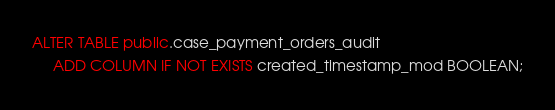Convert code to text. <code><loc_0><loc_0><loc_500><loc_500><_SQL_>ALTER TABLE public.case_payment_orders_audit
     ADD COLUMN IF NOT EXISTS created_timestamp_mod BOOLEAN;
</code> 